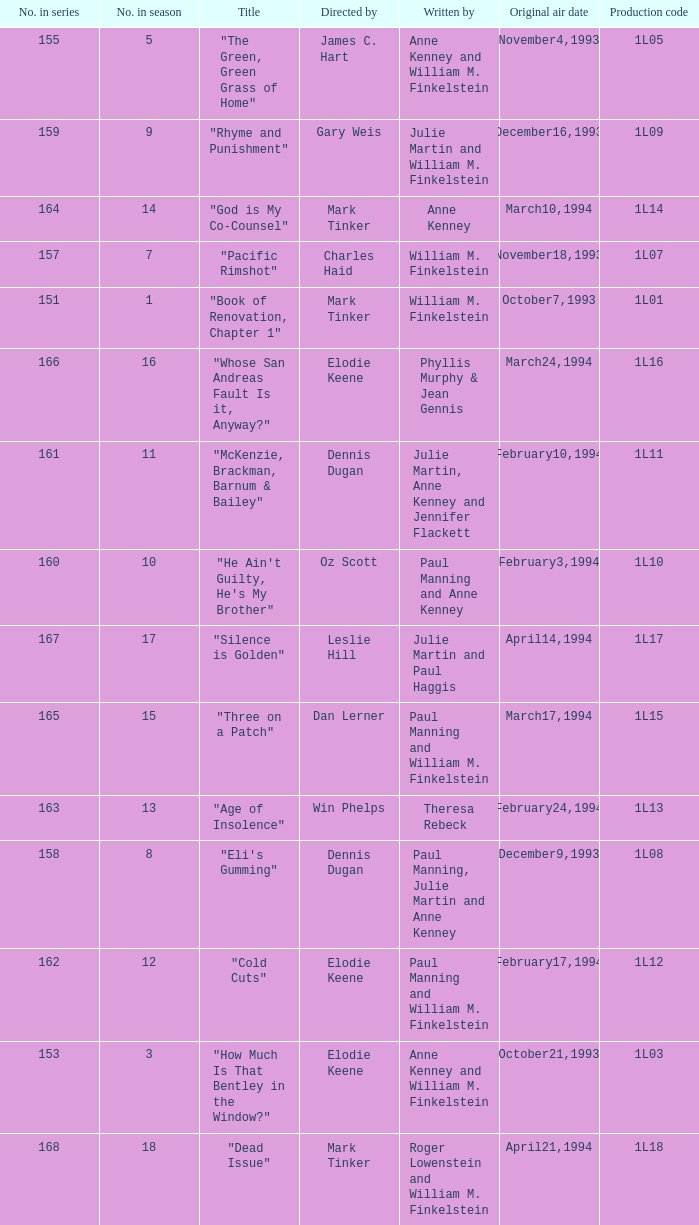Would you mind parsing the complete table? {'header': ['No. in series', 'No. in season', 'Title', 'Directed by', 'Written by', 'Original air date', 'Production code'], 'rows': [['155', '5', '"The Green, Green Grass of Home"', 'James C. Hart', 'Anne Kenney and William M. Finkelstein', 'November4,1993', '1L05'], ['159', '9', '"Rhyme and Punishment"', 'Gary Weis', 'Julie Martin and William M. Finkelstein', 'December16,1993', '1L09'], ['164', '14', '"God is My Co-Counsel"', 'Mark Tinker', 'Anne Kenney', 'March10,1994', '1L14'], ['157', '7', '"Pacific Rimshot"', 'Charles Haid', 'William M. Finkelstein', 'November18,1993', '1L07'], ['151', '1', '"Book of Renovation, Chapter 1"', 'Mark Tinker', 'William M. Finkelstein', 'October7,1993', '1L01'], ['166', '16', '"Whose San Andreas Fault Is it, Anyway?"', 'Elodie Keene', 'Phyllis Murphy & Jean Gennis', 'March24,1994', '1L16'], ['161', '11', '"McKenzie, Brackman, Barnum & Bailey"', 'Dennis Dugan', 'Julie Martin, Anne Kenney and Jennifer Flackett', 'February10,1994', '1L11'], ['160', '10', '"He Ain\'t Guilty, He\'s My Brother"', 'Oz Scott', 'Paul Manning and Anne Kenney', 'February3,1994', '1L10'], ['167', '17', '"Silence is Golden"', 'Leslie Hill', 'Julie Martin and Paul Haggis', 'April14,1994', '1L17'], ['165', '15', '"Three on a Patch"', 'Dan Lerner', 'Paul Manning and William M. Finkelstein', 'March17,1994', '1L15'], ['163', '13', '"Age of Insolence"', 'Win Phelps', 'Theresa Rebeck', 'February24,1994', '1L13'], ['158', '8', '"Eli\'s Gumming"', 'Dennis Dugan', 'Paul Manning, Julie Martin and Anne Kenney', 'December9,1993', '1L08'], ['162', '12', '"Cold Cuts"', 'Elodie Keene', 'Paul Manning and William M. Finkelstein', 'February17,1994', '1L12'], ['153', '3', '"How Much Is That Bentley in the Window?"', 'Elodie Keene', 'Anne Kenney and William M. Finkelstein', 'October21,1993', '1L03'], ['168', '18', '"Dead Issue"', 'Mark Tinker', 'Roger Lowenstein and William M. Finkelstein', 'April21,1994', '1L18']]} Name the production code for theresa rebeck 1L13. 